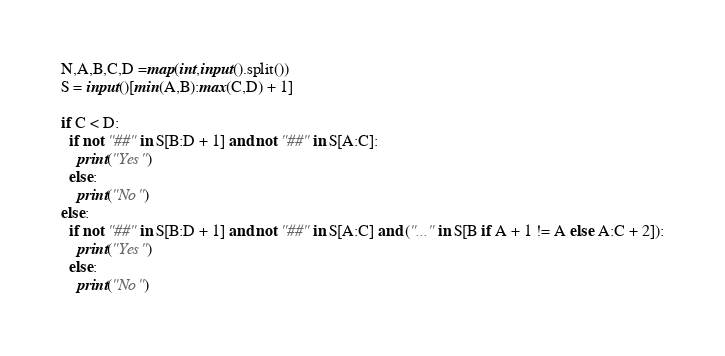<code> <loc_0><loc_0><loc_500><loc_500><_Python_>N,A,B,C,D =map(int,input().split())
S = input()[min(A,B):max(C,D) + 1]

if C < D:
  if not "##" in S[B:D + 1] and not "##" in S[A:C]:
    print("Yes")
  else:
    print("No")
else:
  if not "##" in S[B:D + 1] and not "##" in S[A:C] and ("..." in S[B if A + 1 != A else A:C + 2]):
    print("Yes")
  else:
    print("No")</code> 